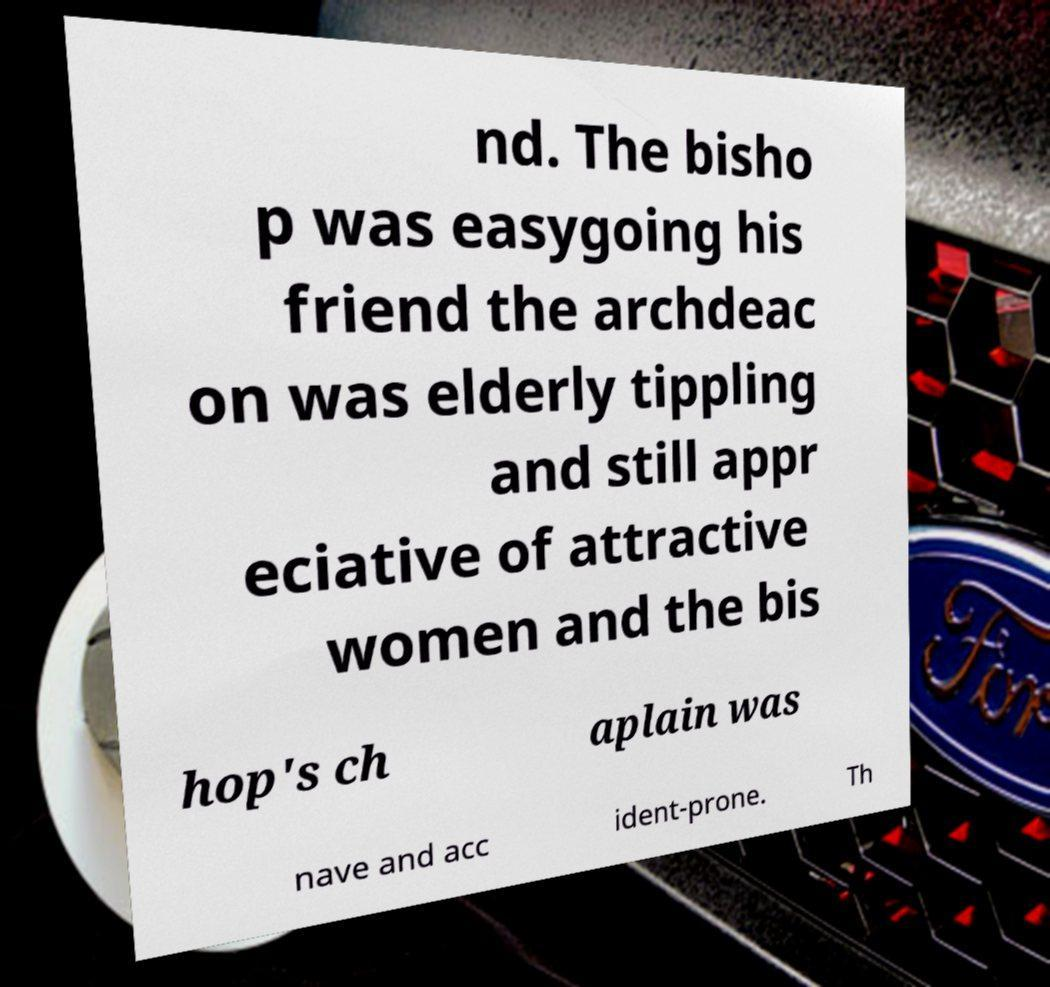Can you read and provide the text displayed in the image?This photo seems to have some interesting text. Can you extract and type it out for me? nd. The bisho p was easygoing his friend the archdeac on was elderly tippling and still appr eciative of attractive women and the bis hop's ch aplain was nave and acc ident-prone. Th 